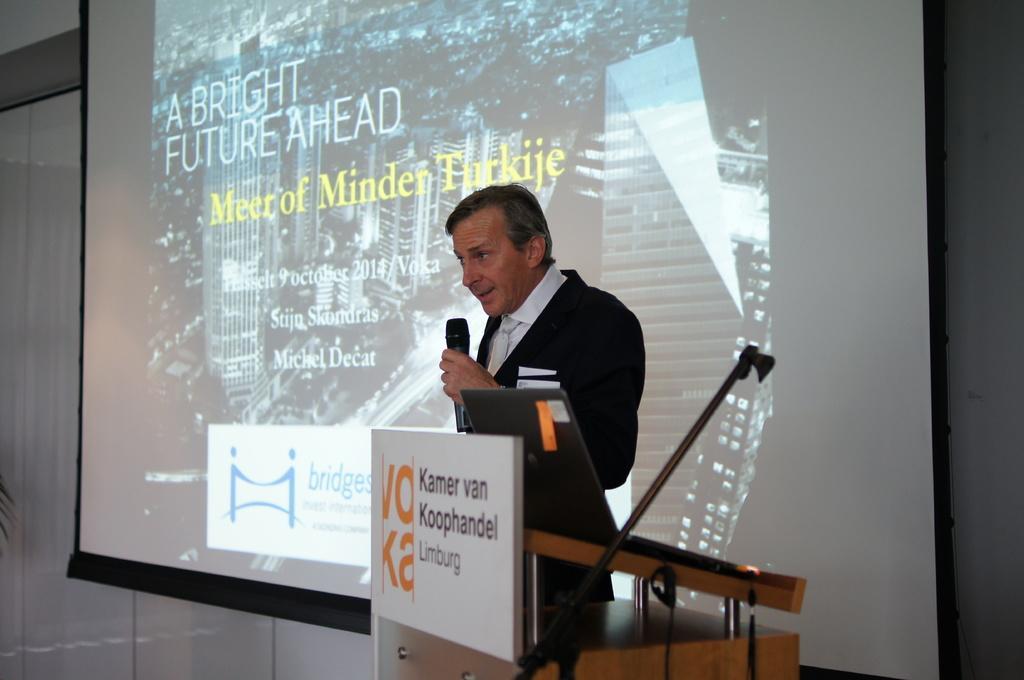How would you summarize this image in a sentence or two? There is a person in the foreground area holding a mic in his hand and there is a desk, laptop, it seems like a mic and poster at the bottom side. There is a projector screen in the background area. 